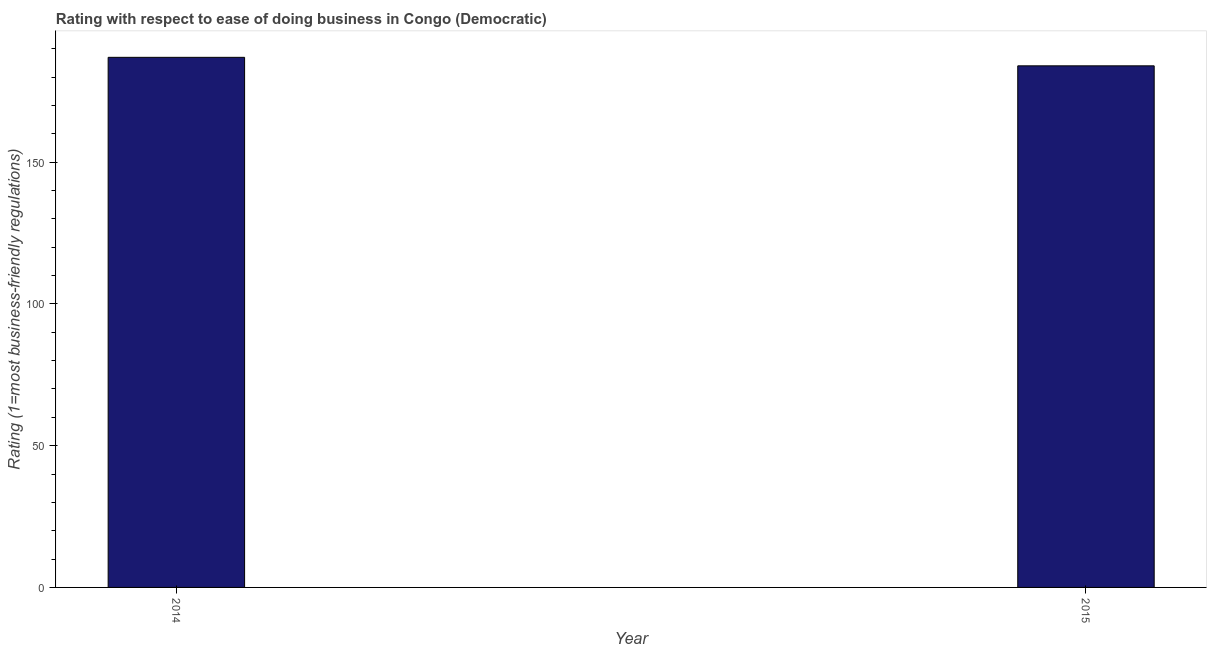Does the graph contain grids?
Offer a terse response. No. What is the title of the graph?
Keep it short and to the point. Rating with respect to ease of doing business in Congo (Democratic). What is the label or title of the X-axis?
Make the answer very short. Year. What is the label or title of the Y-axis?
Make the answer very short. Rating (1=most business-friendly regulations). What is the ease of doing business index in 2014?
Your answer should be compact. 187. Across all years, what is the maximum ease of doing business index?
Offer a terse response. 187. Across all years, what is the minimum ease of doing business index?
Your answer should be very brief. 184. In which year was the ease of doing business index minimum?
Your answer should be compact. 2015. What is the sum of the ease of doing business index?
Offer a very short reply. 371. What is the average ease of doing business index per year?
Your answer should be compact. 185. What is the median ease of doing business index?
Provide a short and direct response. 185.5. In how many years, is the ease of doing business index greater than 50 ?
Make the answer very short. 2. Do a majority of the years between 2015 and 2014 (inclusive) have ease of doing business index greater than 150 ?
Your answer should be compact. No. What is the ratio of the ease of doing business index in 2014 to that in 2015?
Keep it short and to the point. 1.02. Is the ease of doing business index in 2014 less than that in 2015?
Provide a short and direct response. No. How many bars are there?
Your answer should be very brief. 2. How many years are there in the graph?
Provide a succinct answer. 2. What is the Rating (1=most business-friendly regulations) of 2014?
Provide a short and direct response. 187. What is the Rating (1=most business-friendly regulations) of 2015?
Ensure brevity in your answer.  184. What is the ratio of the Rating (1=most business-friendly regulations) in 2014 to that in 2015?
Provide a short and direct response. 1.02. 